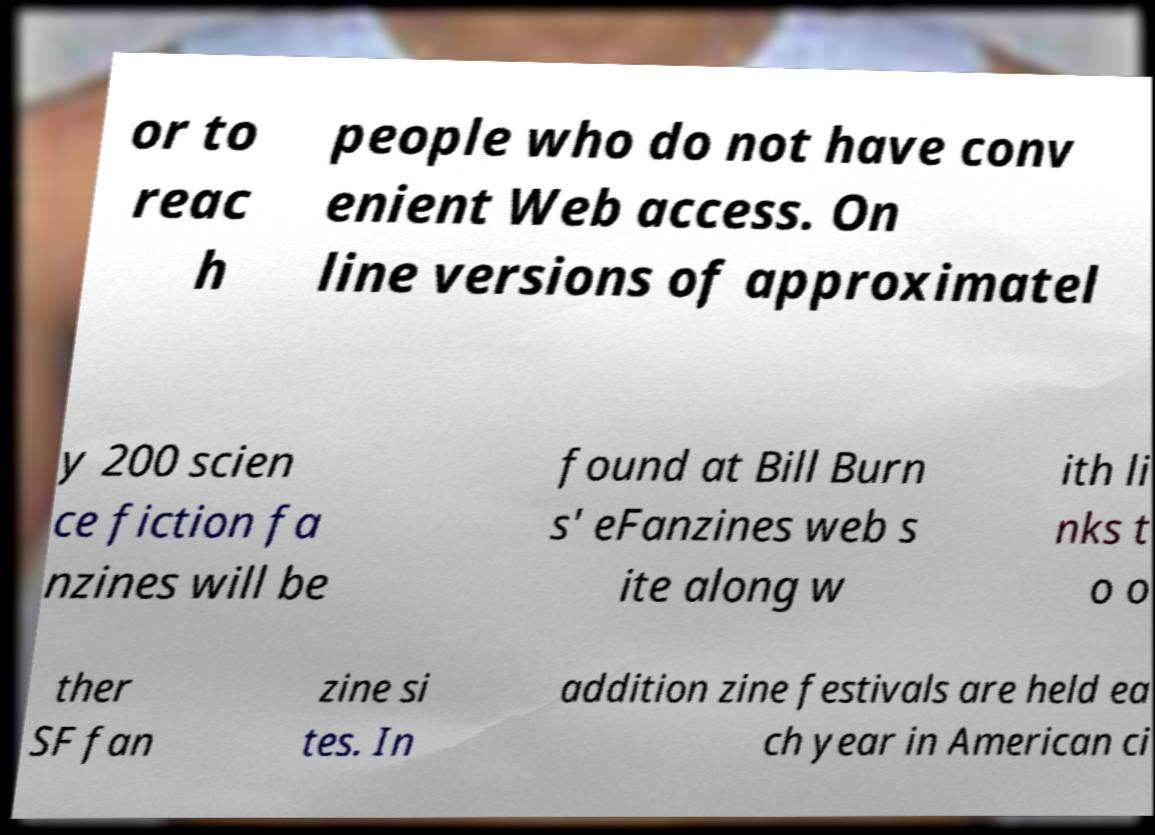I need the written content from this picture converted into text. Can you do that? or to reac h people who do not have conv enient Web access. On line versions of approximatel y 200 scien ce fiction fa nzines will be found at Bill Burn s' eFanzines web s ite along w ith li nks t o o ther SF fan zine si tes. In addition zine festivals are held ea ch year in American ci 